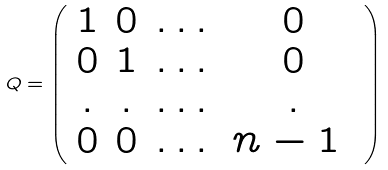Convert formula to latex. <formula><loc_0><loc_0><loc_500><loc_500>Q = \left ( \begin{array} { c c c c } 1 & 0 & \dots & 0 \\ 0 & 1 & \dots & 0 \\ . & . & \dots & . \\ 0 & 0 & \dots & n - 1 \ \end{array} \right )</formula> 